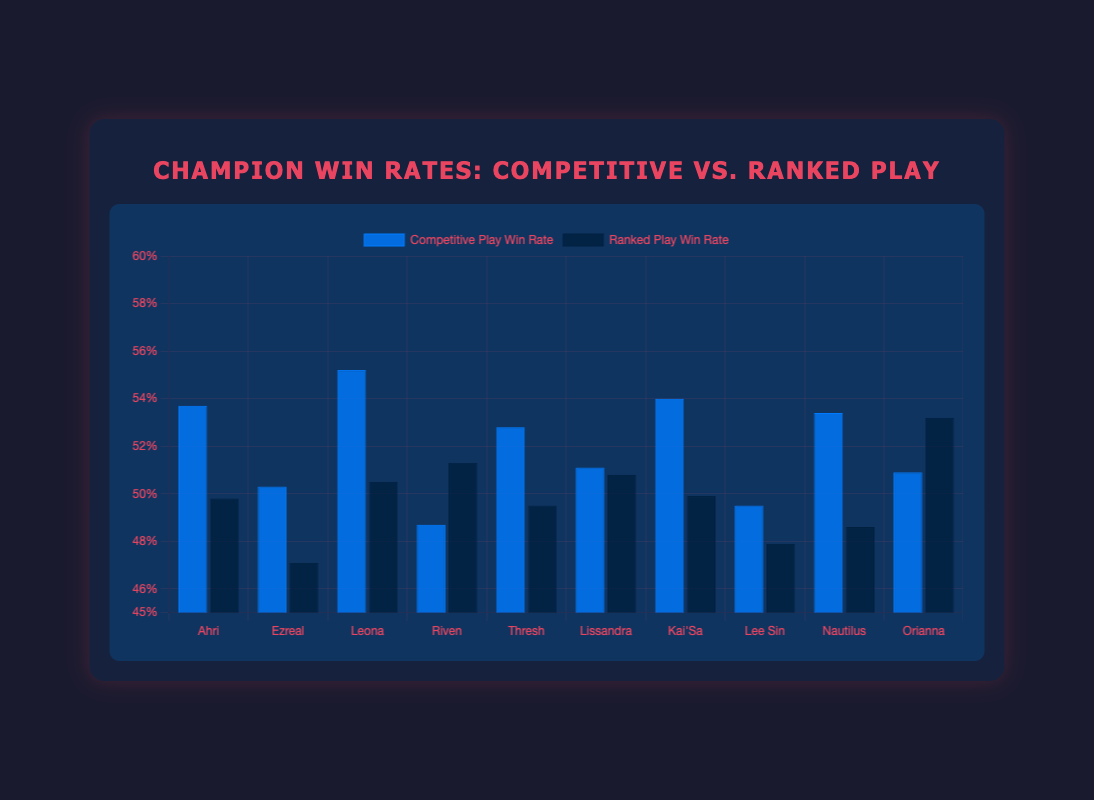Which champion has the highest win rate in Competitive Play? Look at the height of the blue bars and identify the champion with the tallest bar. Leona has the highest win rate in Competitive Play at 55.2%.
Answer: Leona Which champion has the lowest win rate in Ranked Play? Look at the height of the dark blue bars and identify the champion with the shortest bar. Ezreal has the lowest win rate in Ranked Play at 47.1%.
Answer: Ezreal How much higher is Ahri's win rate in Competitive Play compared to Ranked Play? Find Ahri's win rates in both Competitive Play and Ranked Play. The difference is 53.7% - 49.8% = 3.9%.
Answer: 3.9% Which two champions have very close win rates in Ranked Play, almost equal? Compare the heights of the dark blue bars to find the two closest values. Lissandra and Kai'Sa have win rates of 50.8% and 49.9% respectively, which are quite close.
Answer: Lissandra and Kai'Sa What is the average win rate of all champions in Competitive Play? Sum the win rates of all champions in Competitive Play and divide by the number of champions. The sum is 53.7 + 50.3 + 55.2 + 48.7 + 52.8 + 51.1 + 54 + 49.5 + 53.4 + 50.9 = 519.6. Divide by 10: 519.6 / 10 = 51.96%.
Answer: 51.96% Does Riven have a higher win rate in Competitive Play or Ranked Play, and by how much? Compare Riven's win rates in both Competitive Play and Ranked Play. The difference is 51.3% - 48.7% = 2.6%, so Riven is higher in Ranked Play.
Answer: Ranked Play by 2.6% Which champion has a higher win rate difference between Competitive Play and Ranked Play, Lee Sin or Orianna? Calculate the difference for both champions. Lee Sin: 49.5% - 47.9% = 1.6%. Orianna: 53.2% - 50.9% = 2.3%. Orianna has the higher difference.
Answer: Orianna What is the median win rate of champions in Ranked Play? Order the win rates in Ranked Play and find the middle value. Ordered: 47.1, 47.9, 48.6, 49.5, 49.8, 49.9, 50.5, 50.8, 51.3, 53.2. The median is the average of the middle two values: (49.9 + 50.5) / 2 = 50.2%.
Answer: 50.2% How much higher is Leona's win rate in Competitive Play compared to Nautilus's win rate in Ranked Play? Find Leona's win rate in Competitive Play and Nautilus's in Ranked Play. The difference is 55.2% - 48.6% = 6.6%.
Answer: 6.6% Between Thresh and Kai'Sa, which champion has a higher win rate in Competitive Play, and by how much? Compare Thresh's and Kai'Sa's win rates in Competitive Play. The difference is 54% - 52.8% = 1.2%.
Answer: Kai'Sa by 1.2% 